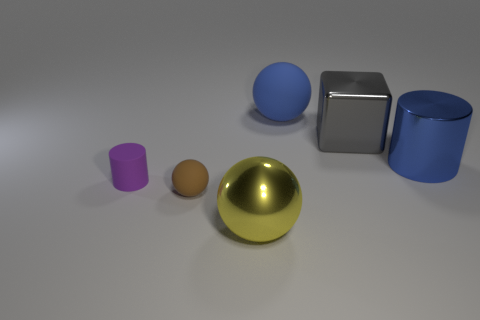Is the color of the large rubber sphere the same as the large cylinder?
Provide a succinct answer. Yes. What number of blue rubber spheres are the same size as the purple matte cylinder?
Ensure brevity in your answer.  0. How many yellow objects are large metal cubes or spheres?
Offer a very short reply. 1. What is the shape of the big metallic thing on the left side of the matte object on the right side of the tiny rubber sphere?
Ensure brevity in your answer.  Sphere. What shape is the yellow object that is the same size as the blue sphere?
Your answer should be very brief. Sphere. Is there a cube that has the same color as the big rubber ball?
Offer a terse response. No. Are there the same number of yellow shiny things that are behind the tiny sphere and tiny spheres that are left of the big gray metal block?
Your response must be concise. No. There is a blue shiny object; is its shape the same as the small object on the left side of the tiny brown matte object?
Your answer should be compact. Yes. How many other things are there of the same material as the tiny purple thing?
Provide a short and direct response. 2. Are there any tiny things on the right side of the small ball?
Offer a terse response. No. 